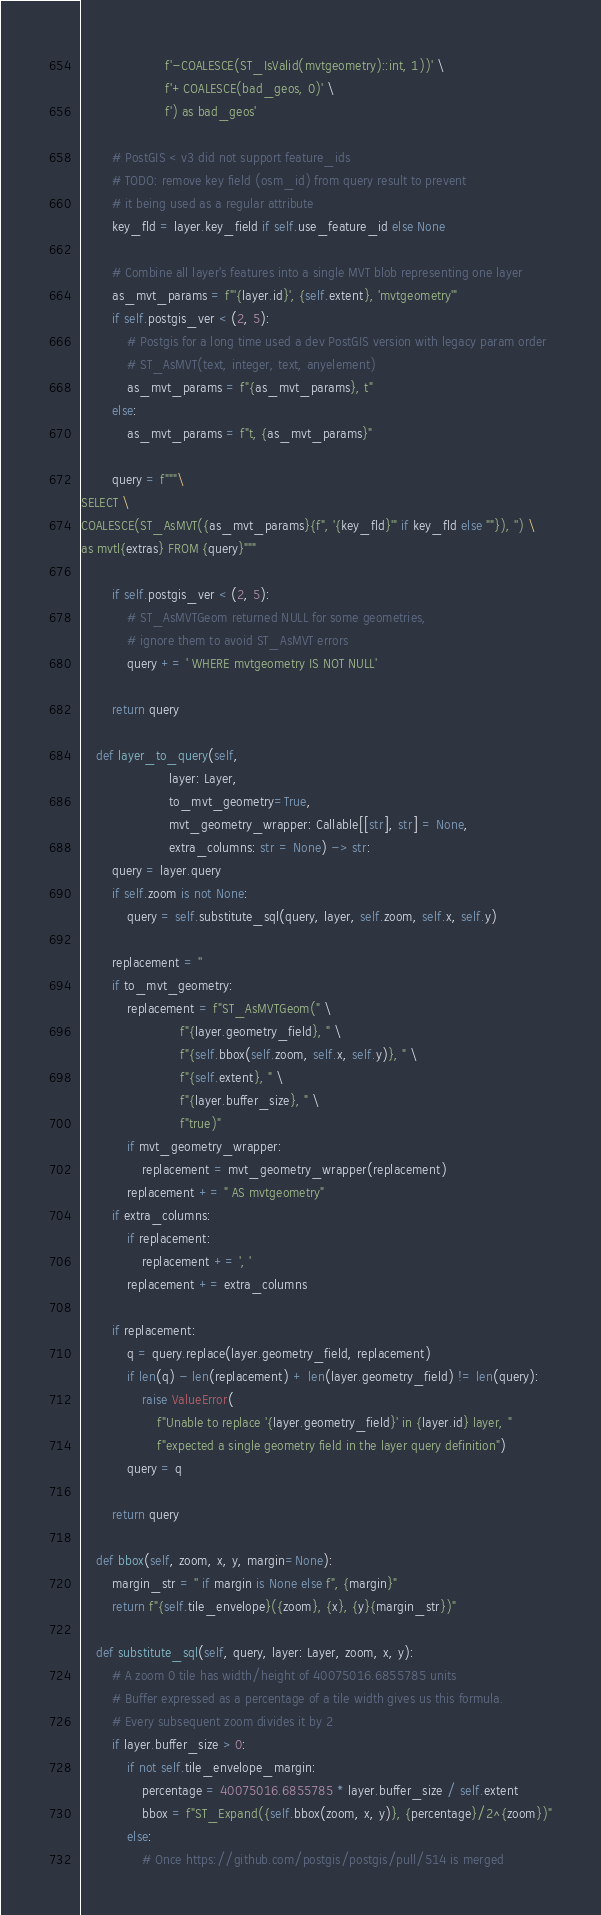Convert code to text. <code><loc_0><loc_0><loc_500><loc_500><_Python_>                      f'-COALESCE(ST_IsValid(mvtgeometry)::int, 1))' \
                      f'+COALESCE(bad_geos, 0)' \
                      f') as bad_geos'

        # PostGIS < v3 did not support feature_ids
        # TODO: remove key field (osm_id) from query result to prevent
        # it being used as a regular attribute
        key_fld = layer.key_field if self.use_feature_id else None

        # Combine all layer's features into a single MVT blob representing one layer
        as_mvt_params = f"'{layer.id}', {self.extent}, 'mvtgeometry'"
        if self.postgis_ver < (2, 5):
            # Postgis for a long time used a dev PostGIS version with legacy param order
            # ST_AsMVT(text, integer, text, anyelement)
            as_mvt_params = f"{as_mvt_params}, t"
        else:
            as_mvt_params = f"t, {as_mvt_params}"

        query = f"""\
SELECT \
COALESCE(ST_AsMVT({as_mvt_params}{f", '{key_fld}'" if key_fld else ""}), '') \
as mvtl{extras} FROM {query}"""

        if self.postgis_ver < (2, 5):
            # ST_AsMVTGeom returned NULL for some geometries,
            # ignore them to avoid ST_AsMVT errors
            query += ' WHERE mvtgeometry IS NOT NULL'

        return query

    def layer_to_query(self,
                       layer: Layer,
                       to_mvt_geometry=True,
                       mvt_geometry_wrapper: Callable[[str], str] = None,
                       extra_columns: str = None) -> str:
        query = layer.query
        if self.zoom is not None:
            query = self.substitute_sql(query, layer, self.zoom, self.x, self.y)

        replacement = ''
        if to_mvt_geometry:
            replacement = f"ST_AsMVTGeom(" \
                          f"{layer.geometry_field}, " \
                          f"{self.bbox(self.zoom, self.x, self.y)}, " \
                          f"{self.extent}, " \
                          f"{layer.buffer_size}, " \
                          f"true)"
            if mvt_geometry_wrapper:
                replacement = mvt_geometry_wrapper(replacement)
            replacement += " AS mvtgeometry"
        if extra_columns:
            if replacement:
                replacement += ', '
            replacement += extra_columns

        if replacement:
            q = query.replace(layer.geometry_field, replacement)
            if len(q) - len(replacement) + len(layer.geometry_field) != len(query):
                raise ValueError(
                    f"Unable to replace '{layer.geometry_field}' in {layer.id} layer, "
                    f"expected a single geometry field in the layer query definition")
            query = q

        return query

    def bbox(self, zoom, x, y, margin=None):
        margin_str = '' if margin is None else f", {margin}"
        return f"{self.tile_envelope}({zoom}, {x}, {y}{margin_str})"

    def substitute_sql(self, query, layer: Layer, zoom, x, y):
        # A zoom 0 tile has width/height of 40075016.6855785 units
        # Buffer expressed as a percentage of a tile width gives us this formula.
        # Every subsequent zoom divides it by 2
        if layer.buffer_size > 0:
            if not self.tile_envelope_margin:
                percentage = 40075016.6855785 * layer.buffer_size / self.extent
                bbox = f"ST_Expand({self.bbox(zoom, x, y)}, {percentage}/2^{zoom})"
            else:
                # Once https://github.com/postgis/postgis/pull/514 is merged</code> 